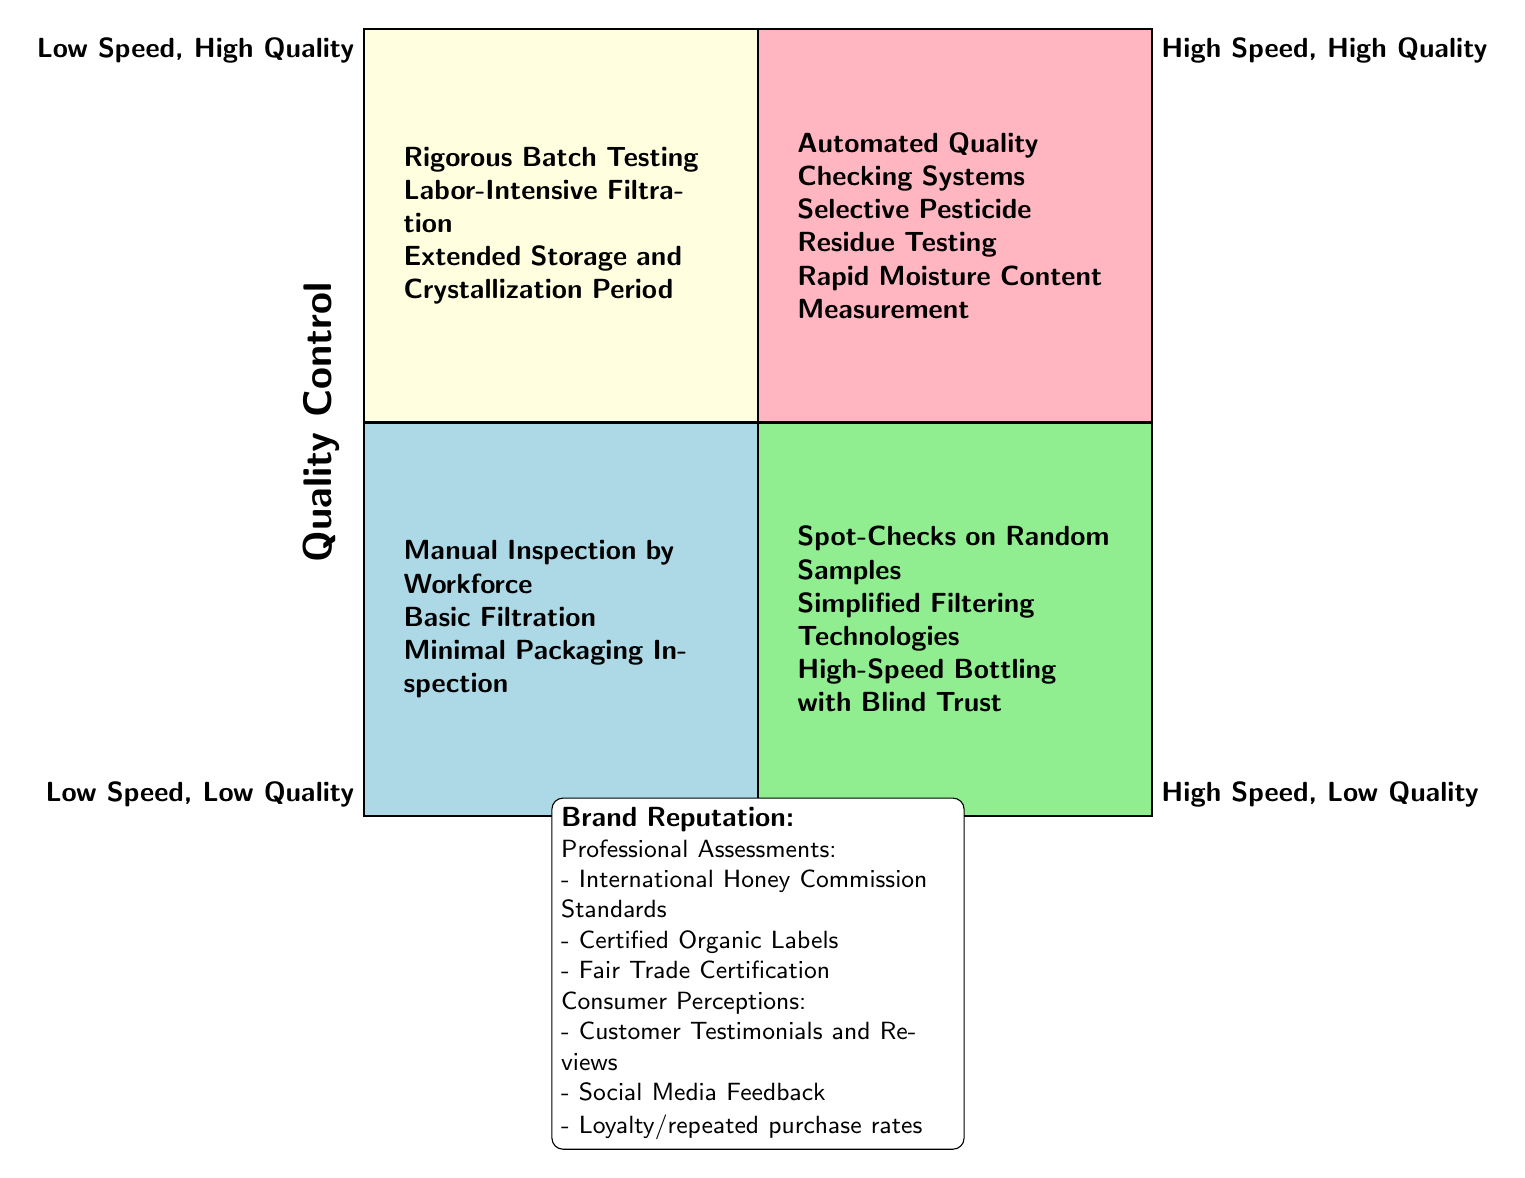What are the three methods listed under Low Speed, High Quality? The methods listed in the Low Speed, High Quality quadrant include "Rigorous Batch Testing," "Labor-Intensive Filtration," and "Extended Storage and Crystallization Period." These are all practices associated with ensuring high-quality honey but require more time to implement.
Answer: Rigorous Batch Testing, Labor-Intensive Filtration, Extended Storage and Crystallization Period How many methods are listed under High Speed, Low Quality? In the High Speed, Low Quality quadrant, there are three methods: "Spot-Checks on Random Samples," "Simplified Filtering Technologies," and "High-Speed Bottling with Blind Trust." Counting these methods gives a total of three.
Answer: 3 Which quadrant contains "Manual Inspection by Workforce"? "Manual Inspection by Workforce" is located in the Low Speed, Low Quality quadrant as it represents a more labor-intensive process associated with lower quality outcomes.
Answer: Low Speed, Low Quality What are the professional assessments and certifications mentioned? The professional assessments and certifications include "International Honey Commission Standards," "Certified Organic Labels," and "Fair Trade Certification." These represent the standards expected for maintaining brand reputation.
Answer: International Honey Commission Standards, Certified Organic Labels, Fair Trade Certification Which quadrant pairs high production speed with high quality? The quadrant that pairs high production speed with high quality is the High Speed, High Quality quadrant. This quadrant represents methods that strive to ensure quality while maximizing production speed.
Answer: High Speed, High Quality What does consumer perception include in terms of brand reputation? Consumer perception in the context of brand reputation includes "Customer Testimonials and Reviews," "Social Media Feedback," and "Loyalty/repeated purchase rates." These factors influence how customers view the brand.
Answer: Customer Testimonials and Reviews, Social Media Feedback, Loyalty/repeated purchase rates How are the quadrants divided in the diagram? The quadrants are divided into four sections based on two axes: Quality Control (high vs. low) and Production Speed (high vs. low). This results in four distinct categories that represent different approaches to honey production.
Answer: Four quadrants based on Quality Control and Production Speed What is the relationship between high speed and quality control in the diagram? The relationship indicates that high speed does not necessarily correlate with high quality, as evident in the quadrant "High Speed, Low Quality," where faster production methods may compromise quality.
Answer: High Speed, Low Quality 